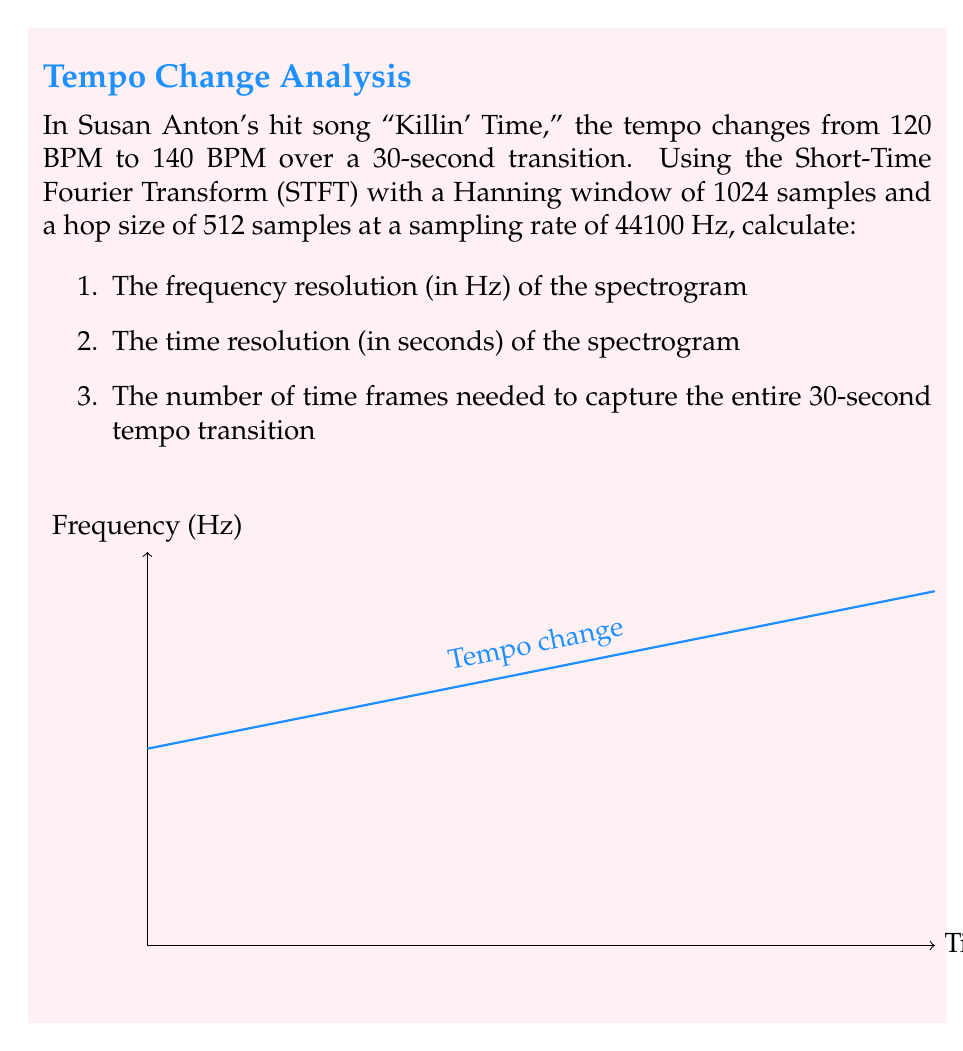Could you help me with this problem? Let's approach this step-by-step:

1) First, we need to calculate the frequency resolution. The frequency resolution is given by:

   $$\Delta f = \frac{f_s}{N}$$

   Where $f_s$ is the sampling rate and $N$ is the window size.

   $$\Delta f = \frac{44100}{1024} \approx 43.07 \text{ Hz}$$

2) The time resolution is determined by the hop size:

   $$\Delta t = \frac{H}{f_s}$$

   Where $H$ is the hop size.

   $$\Delta t = \frac{512}{44100} \approx 0.0116 \text{ seconds}$$

3) To find the number of time frames needed for the 30-second transition:

   $$\text{Number of frames} = \frac{\text{Transition time}}{\text{Time resolution}}$$

   $$\text{Number of frames} = \frac{30}{0.0116} \approx 2586.21$$

   We round up to the nearest whole number: 2587 frames.
Answer: Frequency resolution: 43.07 Hz, Time resolution: 0.0116 s, Number of frames: 2587 